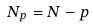Convert formula to latex. <formula><loc_0><loc_0><loc_500><loc_500>N _ { p } = N - p</formula> 